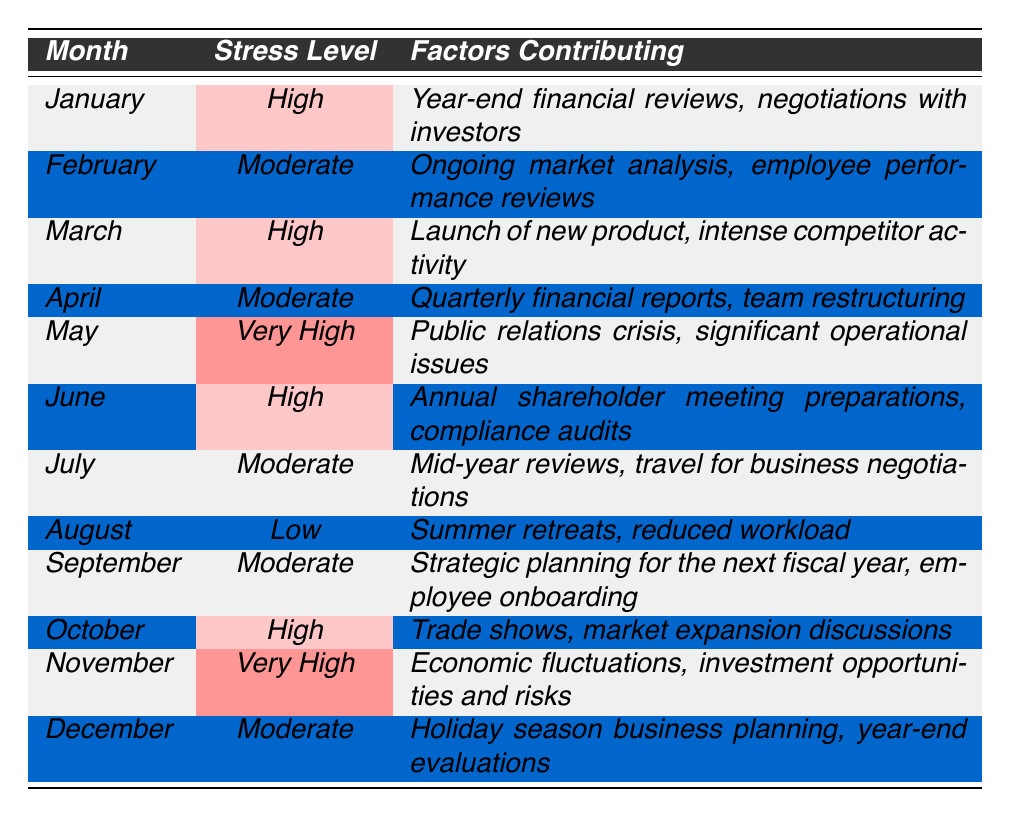What is the stress level in May? The table indicates that the stress level for May is labeled as "Very High."
Answer: Very High How many months had a stress level classified as 'Moderate'? By reviewing the table, the months with a "Moderate" stress level are February, April, July, September, and December, making a total of 5 months.
Answer: 5 Which month had the highest stress level? Looking at the stress levels in the table, May and November both have a stress level of "Very High," indicating they tie for the highest level.
Answer: May and November What were the factors contributing to the high stress level in June? The contributing factors for June are listed as "Annual shareholder meeting preparations, compliance audits."
Answer: Annual shareholder meeting preparations, compliance audits Is it true that August had a high stress level? Checking the table, August has a "Low" stress level, confirming the statement is false.
Answer: No What is the difference in stress levels between January and April? January has a "High" stress level, while April has a "Moderate" stress level. The difference suggests that January is higher than April, implying a drop in stress level.
Answer: High to Moderate How many months experienced a stress level of 'High' or 'Very High'? The months with stress levels of "High" (January, March, June, October) and "Very High" (May, November) total 6 months when combined.
Answer: 6 Which month had the median stress level? The stress levels in order are Low, Moderate, Moderate, Moderate, High, High, High, Very High, Very High, High. The median falls at the 6th position in this ordered list, corresponding to a "High" stress in June.
Answer: High What factors contributed to the very high stress level in November? For November, the contributing factors listed are "Economic fluctuations, investment opportunities and risks."
Answer: Economic fluctuations, investment opportunities and risks In which month was the stress level the lowest? The table shows that August had the lowest stress level categorized as "Low."
Answer: August 